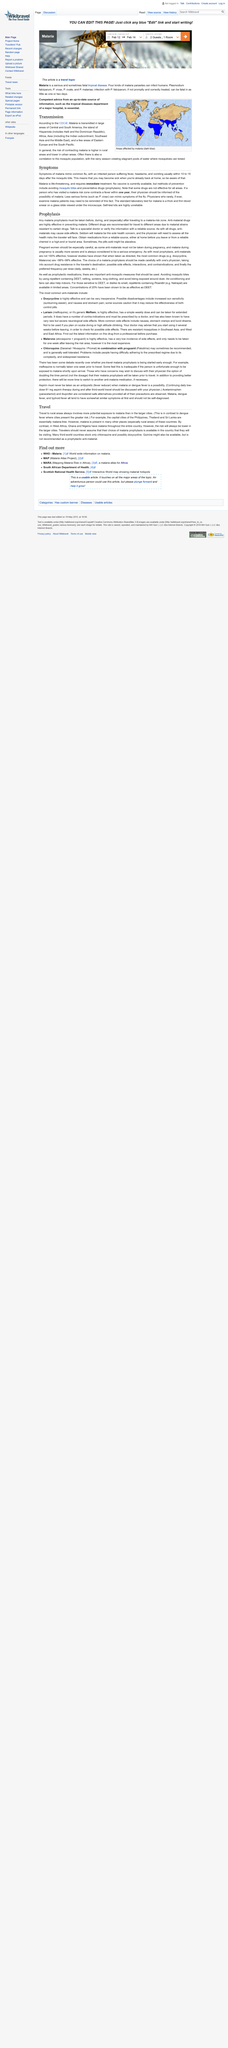Point out several critical features in this image. Malaria is a disease that mimics the symptoms of the common flu, making it difficult to distinguish between the two. Malaria is life-threatening and requires immediate treatment. Malaria is a serious disease that can be prevented through one method of avoiding mosquito bites. 